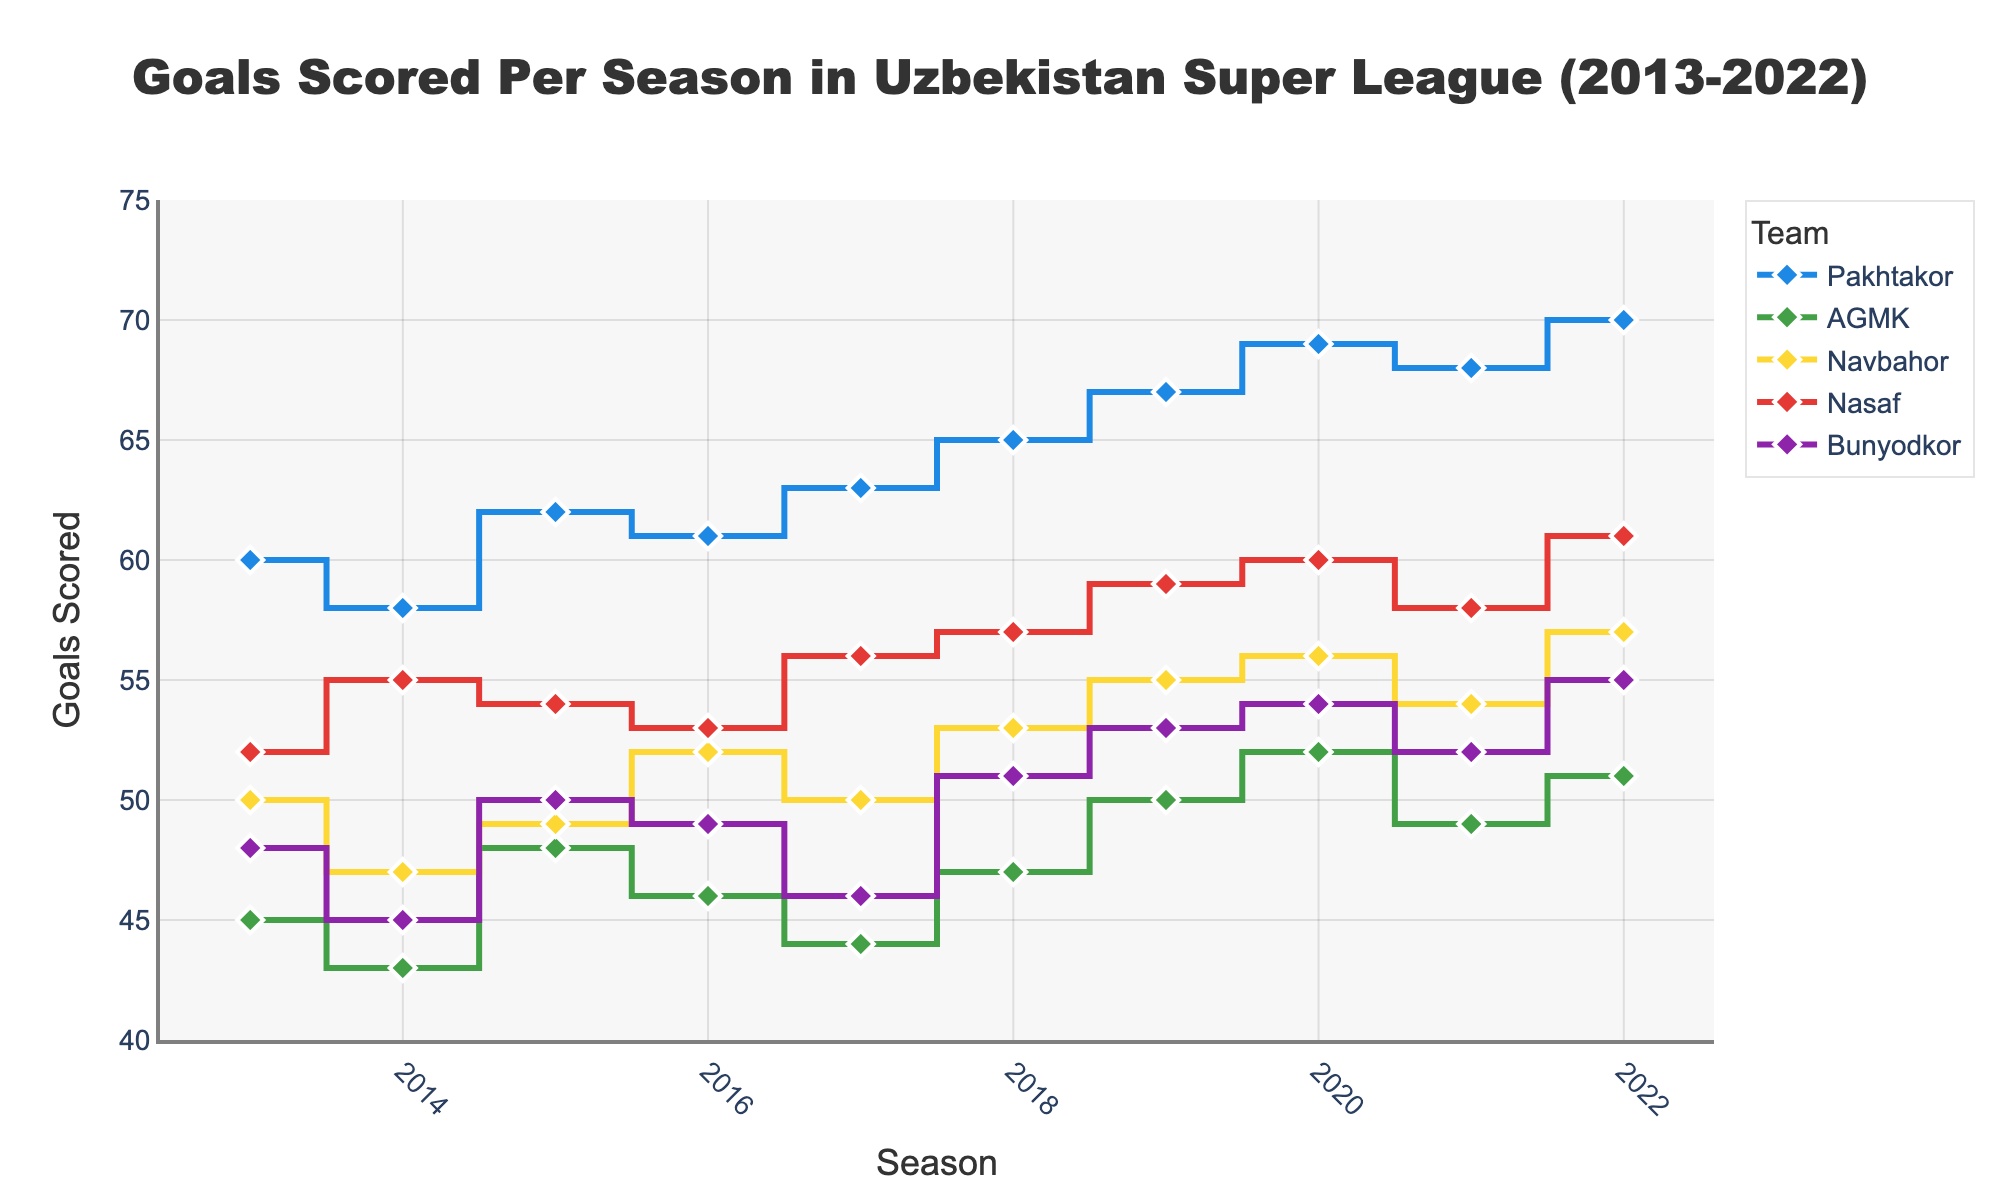Which team scored the most goals in 2022? The data shows the goals scored by each team in 2022. By checking the values, we see that Pakhtakor scored the most with 70 goals.
Answer: Pakhtakor How many goals did AGMK score in 2013 and 2014 combined? By looking at 2013 and 2014 data for AGMK, we find that in 2013 they scored 45 goals and in 2014 they scored 43 goals. Adding these gives 45 + 43 = 88.
Answer: 88 Which team showed the largest increase in goals scored from 2015 to 2016? Checking the goals scored in 2015 and 2016 for all teams: Pakhtakor (62 to 61), AGMK (48 to 46), Navbahor (49 to 52), Nasaf (54 to 53), and Bunyodkor (50 to 49). Navbahor increased by 3 goals (52 - 49).
Answer: Navbahor From 2013 to 2022, which team had the most stable (least varying) goal scoring pattern? Calculating the range (difference between max and min goals) for each team: Pakhtakor (70-58=12), AGMK (52-43=9), Navbahor (57-47=10), Nasaf (61-52=9), Bunyodkor (55-45=10). AGMK and Nasaf have the least variation with a range of 9.
Answer: AGMK, Nasaf What is the average number of goals scored by Bunyodkor over this decade? Summing the goals Bunyodkor scored from 2013 to 2022: 48, 45, 50, 49, 46, 51, 53, 54, 52, 55. The total is 503. There are 10 years, so 503/10 = 50.3.
Answer: 50.3 Which seasons did Nasaf score more than 55 goals? By inspecting Nasaf's data for all seasons: only in 2019 (59), 2020 (60), and 2022 (61) do they score more than 55 goals.
Answer: 2019, 2020, 2022 Compare the goal trends of Pakhtakor and Bunyodkor: did they both increase every year? Examining the yearly data for both teams: Pakhtakor increased every year except from 2020 to 2021; Bunyodkor did not have a consistent increasing trend.
Answer: No What was the total number of goals scored by the top 5 teams in 2016? Summing the 2016 goals for all top 5 teams: Pakhtakor (61), AGMK (46), Navbahor (52), Nasaf (53), Bunyodkor (49). Total is 61 + 46 + 52 + 53 + 49 = 261.
Answer: 261 Which team had the biggest drop in goals scored from one season to the next in this decade? Comparing the year-to-year changes for each team: Bunyodkor drops from 51 in 2018 to 46 in 2017, a decrease of 5 goals (51-46=5). This is the largest drop.
Answer: Bunyodkor In which year did all teams collectively score the most goals? Summing the goals for each year: the highest sum is in 2022 where the total is 70 + 51 + 57 + 61 + 55 = 294.
Answer: 2022 